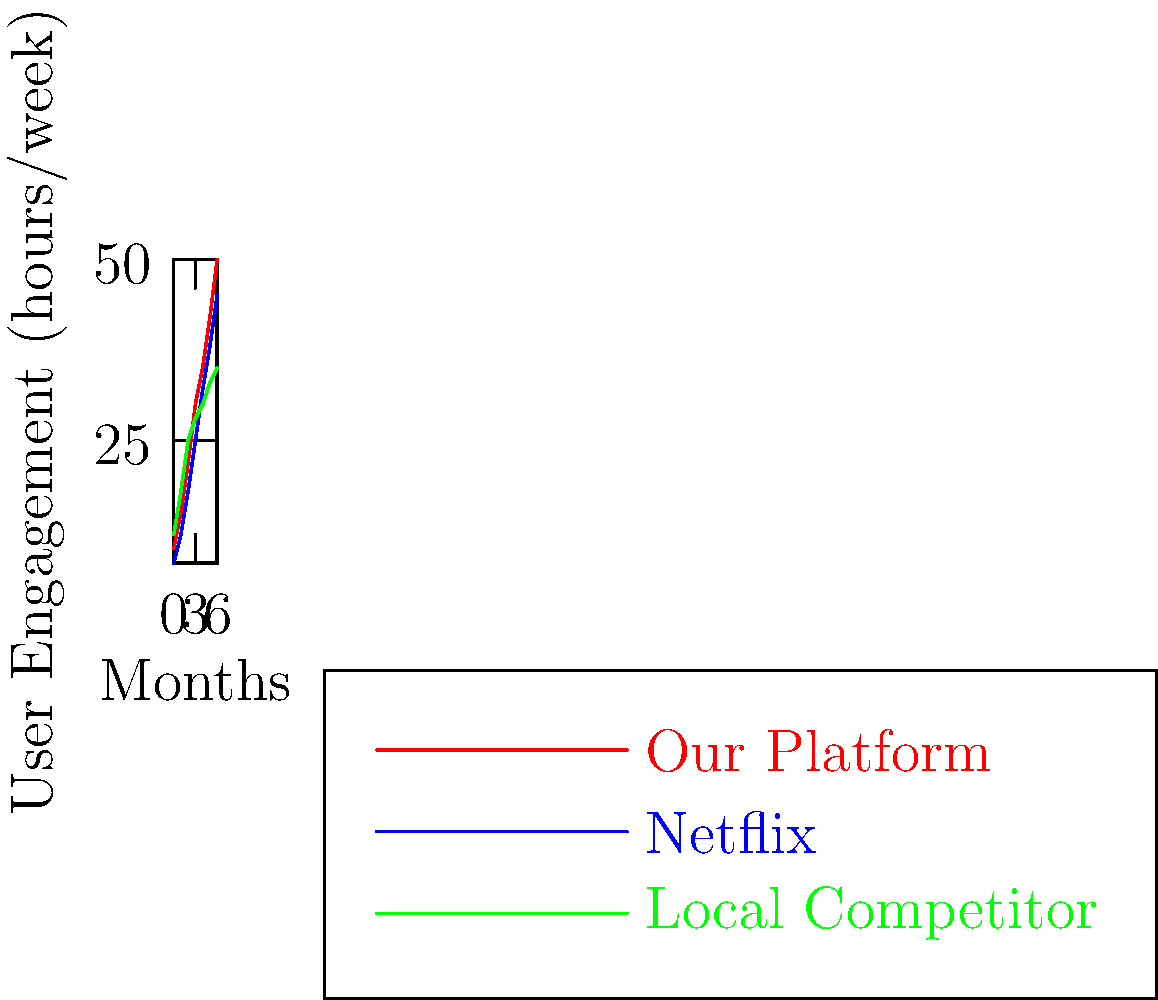Based on the line graph showing user engagement trends across different streaming platforms in the Middle East over a 6-month period, which platform is experiencing the most rapid growth, and what strategic implications does this have for our rival platform? To answer this question, let's analyze the graph step-by-step:

1. Identify the platforms:
   - Red line: Our Platform
   - Blue line: Netflix
   - Green line: Local Competitor

2. Observe the growth trends:
   - Our Platform: Starts at 10 hours/week and ends at 50 hours/week
   - Netflix: Starts at 8 hours/week and ends at 45 hours/week
   - Local Competitor: Starts at 12 hours/week and ends at 35 hours/week

3. Calculate the growth rate:
   - Our Platform: (50 - 10) / 10 = 400% growth
   - Netflix: (45 - 8) / 8 = 462.5% growth
   - Local Competitor: (35 - 12) / 12 = 191.7% growth

4. Compare growth rates:
   Netflix has the highest growth rate at 462.5%, followed closely by Our Platform at 400%.

5. Strategic implications:
   a) Netflix is gaining market share rapidly, posing a significant threat.
   b) Our Platform is also growing fast, indicating strong potential.
   c) The Local Competitor is falling behind, suggesting an opportunity to capture their market share.

6. Potential strategies:
   a) Invest in content acquisition to compete with Netflix's library.
   b) Focus on local content to differentiate from Netflix and appeal to the Middle Eastern audience.
   c) Improve user experience and features to maintain growth momentum.
   d) Consider partnerships or acquisitions to accelerate growth and compete with Netflix.
Answer: Netflix; invest in content, focus on localization, improve UX, consider partnerships/acquisitions. 